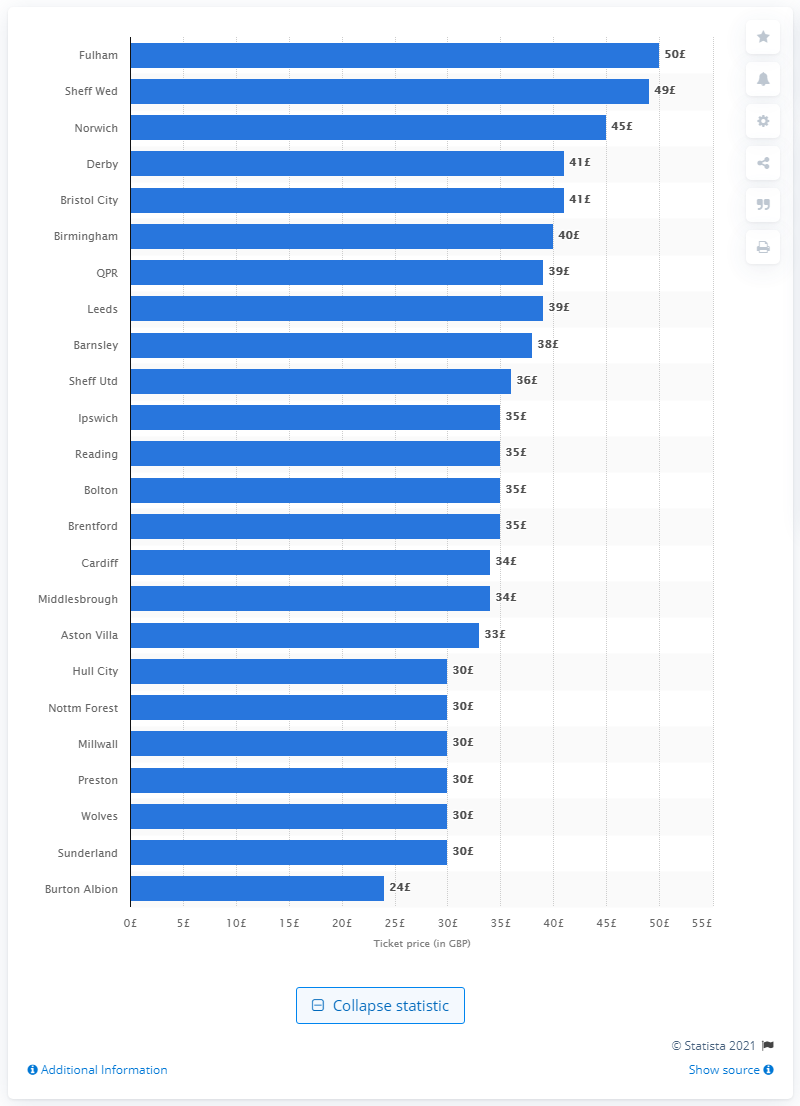Give some essential details in this illustration. The most expensive matchday ticket in the 2017/2018 season was held by Fulham. 